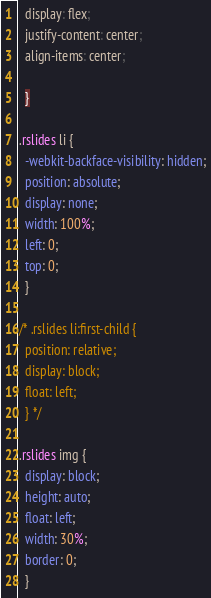Convert code to text. <code><loc_0><loc_0><loc_500><loc_500><_CSS_>  display: flex;
  justify-content: center;
  align-items: center;

  }

.rslides li {
  -webkit-backface-visibility: hidden;
  position: absolute;
  display: none;
  width: 100%;
  left: 0;
  top: 0;
  }

/* .rslides li:first-child {
  position: relative;
  display: block;
  float: left;
  } */

.rslides img {
  display: block;
  height: auto;
  float: left;
  width: 30%;
  border: 0;
  }
</code> 